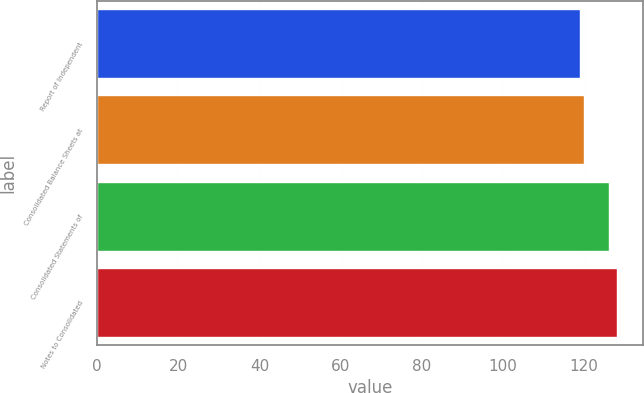Convert chart. <chart><loc_0><loc_0><loc_500><loc_500><bar_chart><fcel>Report of Independent<fcel>Consolidated Balance Sheets at<fcel>Consolidated Statements of<fcel>Notes to Consolidated<nl><fcel>119<fcel>120<fcel>126<fcel>128<nl></chart> 